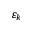Convert formula to latex. <formula><loc_0><loc_0><loc_500><loc_500>\varepsilon _ { k }</formula> 